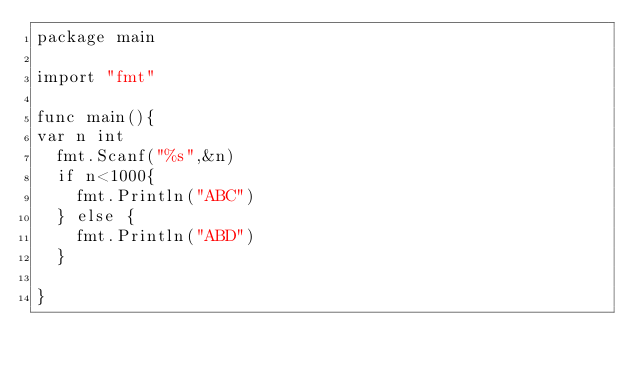<code> <loc_0><loc_0><loc_500><loc_500><_Go_>package main

import "fmt"

func main(){
var n int
  fmt.Scanf("%s",&n)
  if n<1000{
    fmt.Println("ABC")
  } else {
    fmt.Println("ABD")
  }

}</code> 